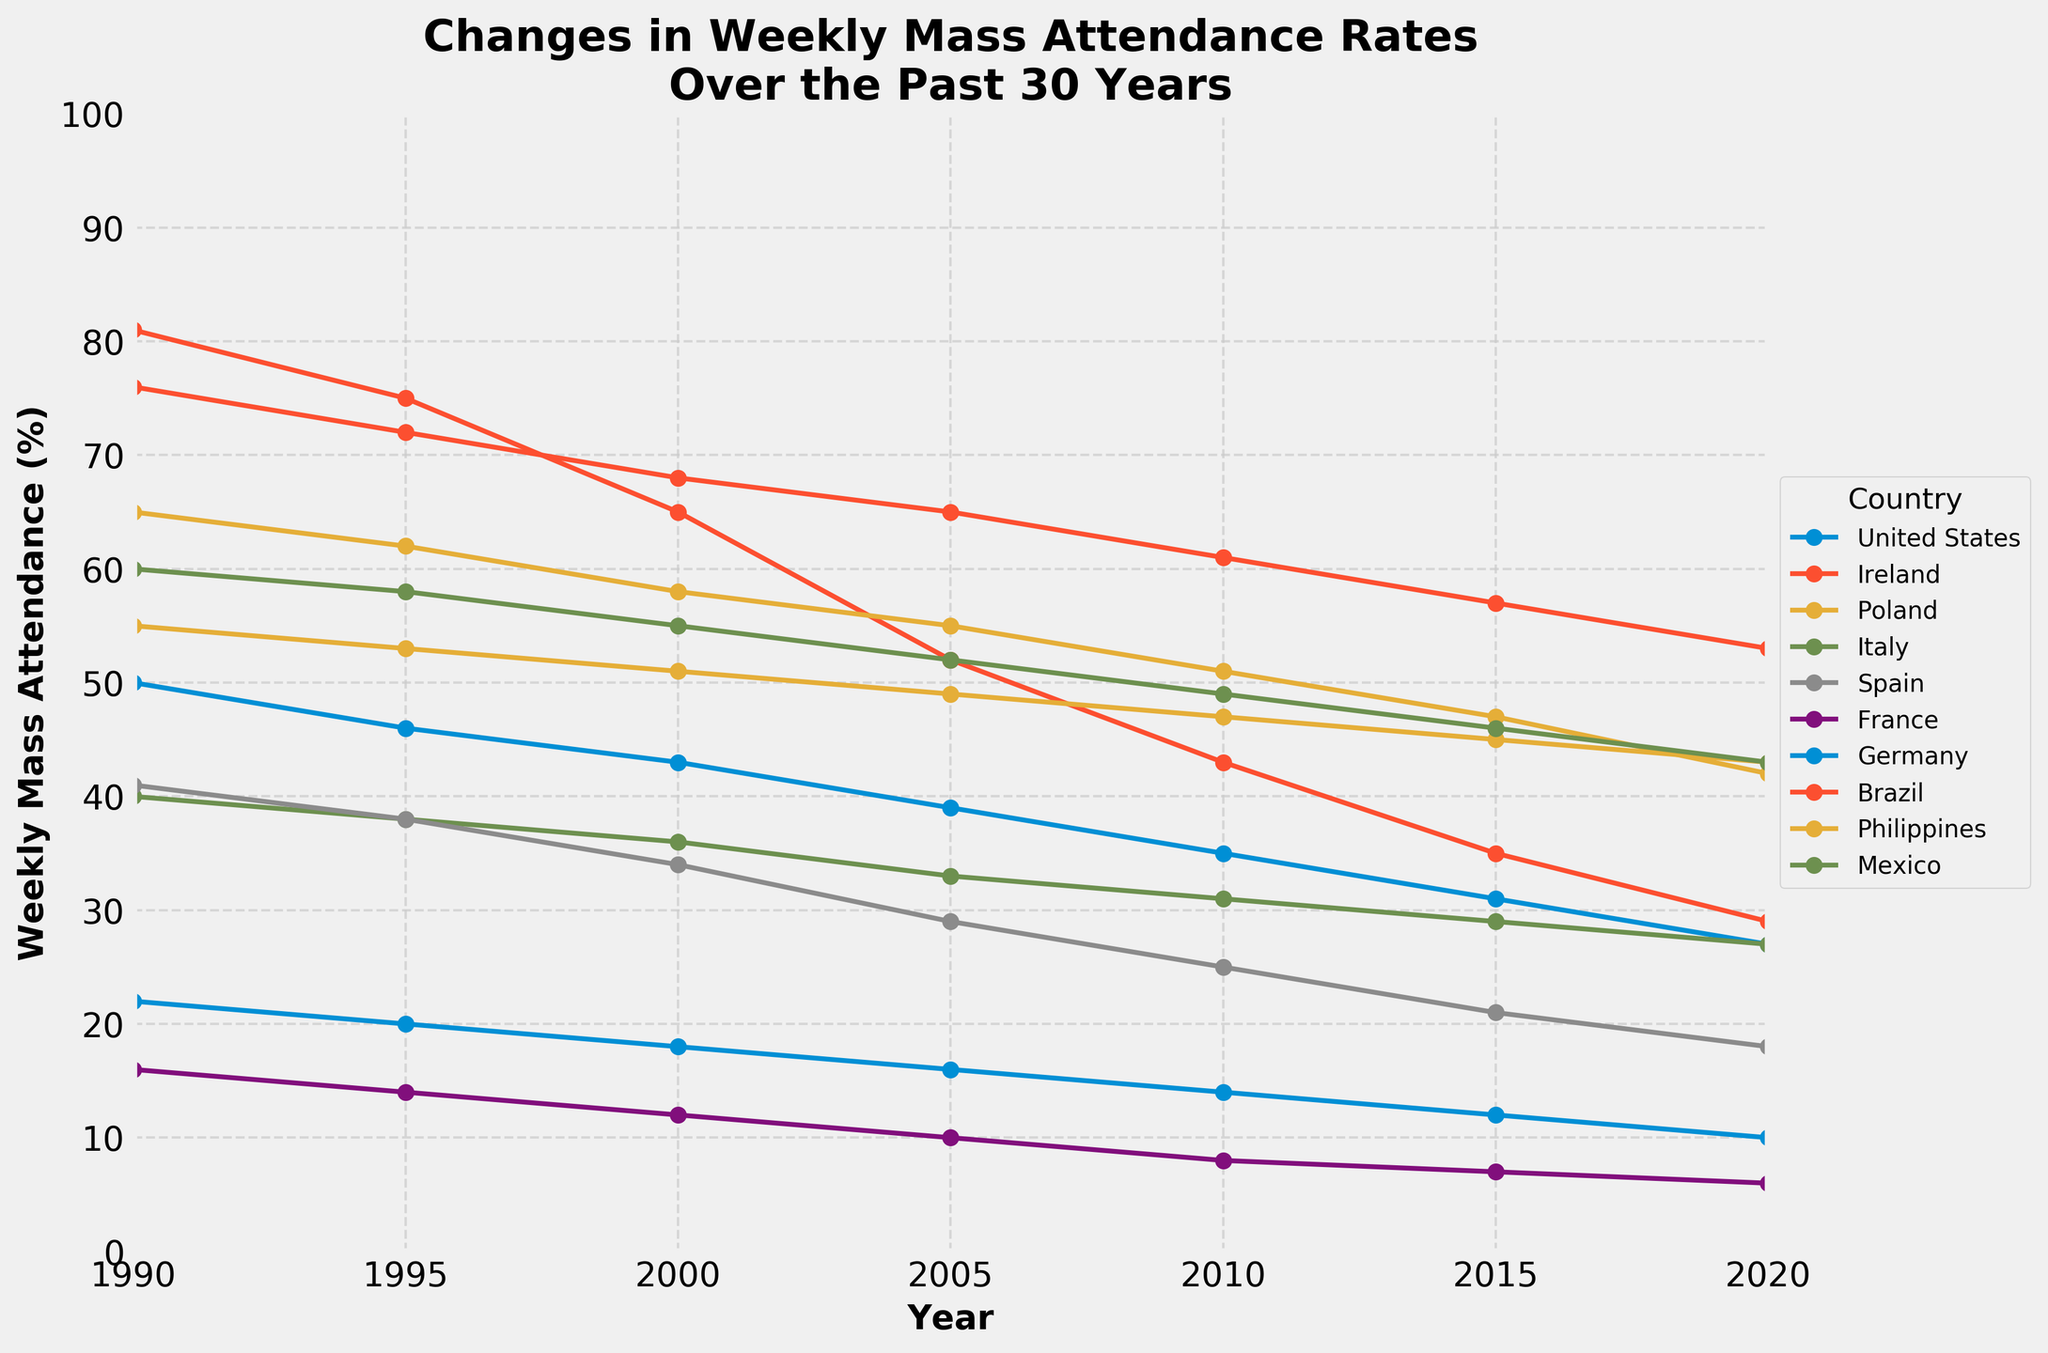What's the overall trend observed in Mass attendance for all countries over the 30 years? By closely examining the lines for all countries, all of them show a downward trend in attendance rates over the 30 years. Thus, the overall trend is a decline in Mass attendance.
Answer: Decline Which country had the highest weekly Mass attendance in 1990? By checking the y-values of all lines at the 1990 mark, Ireland has the highest attendance rate at 81%.
Answer: Ireland Between which two years did Spain see the steepest decline in weekly Mass attendance? Looking closely at the slope of the line for Spain, the steepest decline is observed between 2000 and 2005
Answer: 2000 and 2005 Which country had the smallest change in weekly Mass attendance rate from 1990 to 2020? Subtract the 2020 rate from the 1990 rate for each country and identify the smallest change. The Philippines' rates from 55% to 43% yield the smallest change of 12%.
Answer: Philippines Compare the weekly Mass attendance rates in 2015 for Italy and France. Which country had a higher rate? Compare the y-values of the lines for Italy and France at the 2015 mark. Italy had an attendance rate of 29%, whereas France had a rate of 7%. Therefore, Italy had a higher rate.
Answer: Italy Which country had a consistent decline in weekly Mass attendance from every recorded year to the next? By examining the lines, each country shows a consistent decline from year to year with no increases observed in any interval.
Answer: All countries How many countries had a weekly Mass attendance rate below 40% in 2020? Check the y-values of all countries at the 2020 mark. United States, Ireland, Italy, Spain, France, and Germany have rates below 40%.
Answer: 6 Which country had a higher percentage of weekly Mass attendance in 2010: Mexico or Spain? Compare the y-values for Mexico and Spain at the 2010 mark. Mexico had an attendance rate of 49%, while Spain had a rate of 25%. So, Mexico had a higher rate.
Answer: Mexico 